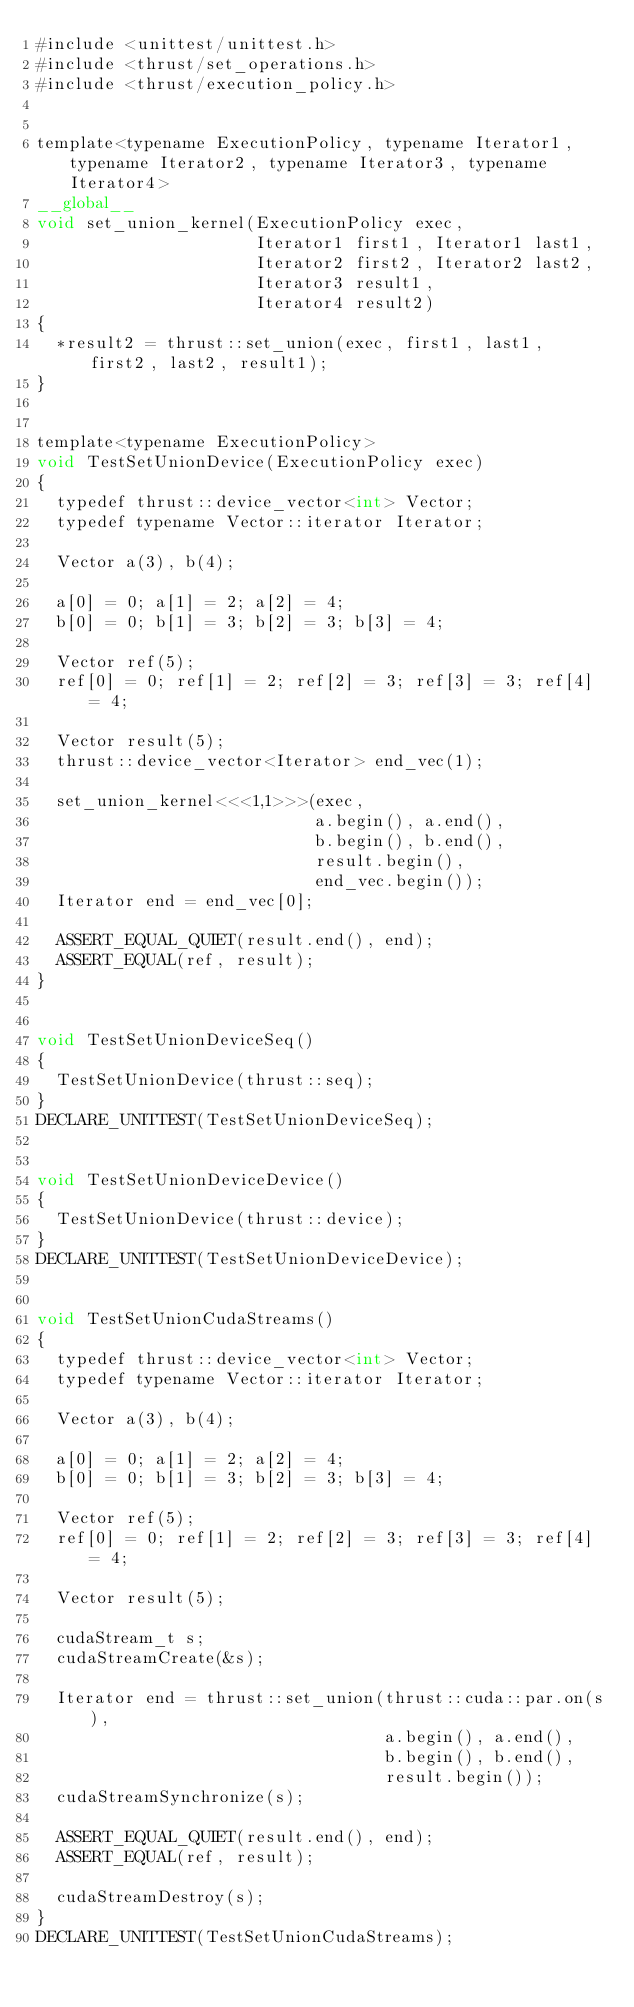<code> <loc_0><loc_0><loc_500><loc_500><_Cuda_>#include <unittest/unittest.h>
#include <thrust/set_operations.h>
#include <thrust/execution_policy.h>


template<typename ExecutionPolicy, typename Iterator1, typename Iterator2, typename Iterator3, typename Iterator4>
__global__
void set_union_kernel(ExecutionPolicy exec,
                      Iterator1 first1, Iterator1 last1,
                      Iterator2 first2, Iterator2 last2,
                      Iterator3 result1,
                      Iterator4 result2)
{
  *result2 = thrust::set_union(exec, first1, last1, first2, last2, result1);
}


template<typename ExecutionPolicy>
void TestSetUnionDevice(ExecutionPolicy exec)
{
  typedef thrust::device_vector<int> Vector;
  typedef typename Vector::iterator Iterator;

  Vector a(3), b(4);

  a[0] = 0; a[1] = 2; a[2] = 4;
  b[0] = 0; b[1] = 3; b[2] = 3; b[3] = 4;

  Vector ref(5);
  ref[0] = 0; ref[1] = 2; ref[2] = 3; ref[3] = 3; ref[4] = 4;

  Vector result(5);
  thrust::device_vector<Iterator> end_vec(1);

  set_union_kernel<<<1,1>>>(exec,
                            a.begin(), a.end(),
                            b.begin(), b.end(),
                            result.begin(),
                            end_vec.begin());
  Iterator end = end_vec[0];

  ASSERT_EQUAL_QUIET(result.end(), end);
  ASSERT_EQUAL(ref, result);
}


void TestSetUnionDeviceSeq()
{
  TestSetUnionDevice(thrust::seq);
}
DECLARE_UNITTEST(TestSetUnionDeviceSeq);


void TestSetUnionDeviceDevice()
{
  TestSetUnionDevice(thrust::device);
}
DECLARE_UNITTEST(TestSetUnionDeviceDevice);


void TestSetUnionCudaStreams()
{
  typedef thrust::device_vector<int> Vector;
  typedef typename Vector::iterator Iterator;

  Vector a(3), b(4);

  a[0] = 0; a[1] = 2; a[2] = 4;
  b[0] = 0; b[1] = 3; b[2] = 3; b[3] = 4;

  Vector ref(5);
  ref[0] = 0; ref[1] = 2; ref[2] = 3; ref[3] = 3; ref[4] = 4;

  Vector result(5);

  cudaStream_t s;
  cudaStreamCreate(&s);

  Iterator end = thrust::set_union(thrust::cuda::par.on(s),
                                   a.begin(), a.end(),
                                   b.begin(), b.end(),
                                   result.begin());
  cudaStreamSynchronize(s);

  ASSERT_EQUAL_QUIET(result.end(), end);
  ASSERT_EQUAL(ref, result);

  cudaStreamDestroy(s);
}
DECLARE_UNITTEST(TestSetUnionCudaStreams);

</code> 